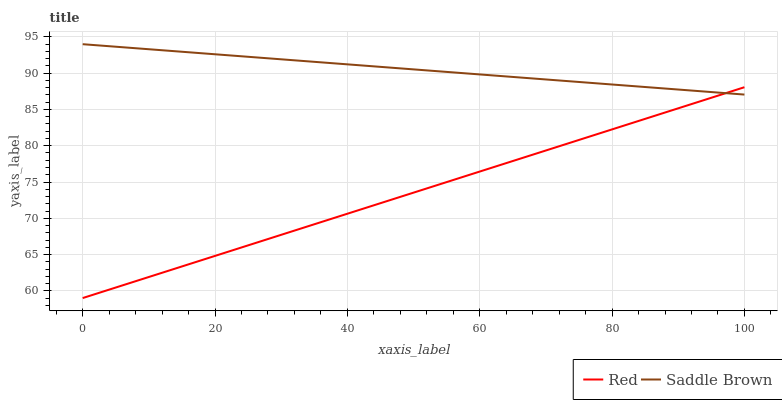Does Red have the maximum area under the curve?
Answer yes or no. No. Is Red the roughest?
Answer yes or no. No. Does Red have the highest value?
Answer yes or no. No. 